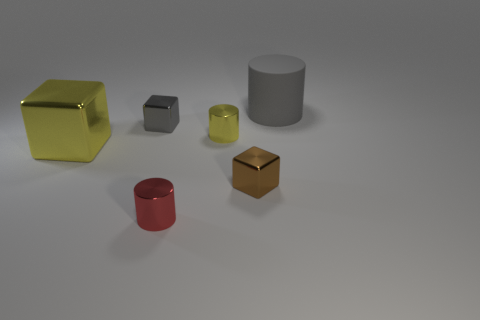What could be the purpose of these objects? The objects in the image might serve several purposes. They could be props for a visual composition or a demonstration of 3D modeling. They might also be teaching tools for understanding shapes and colors or part of a set design to establish a certain aesthetic. The specific context isn't clear, but these are some potential uses for such items. 